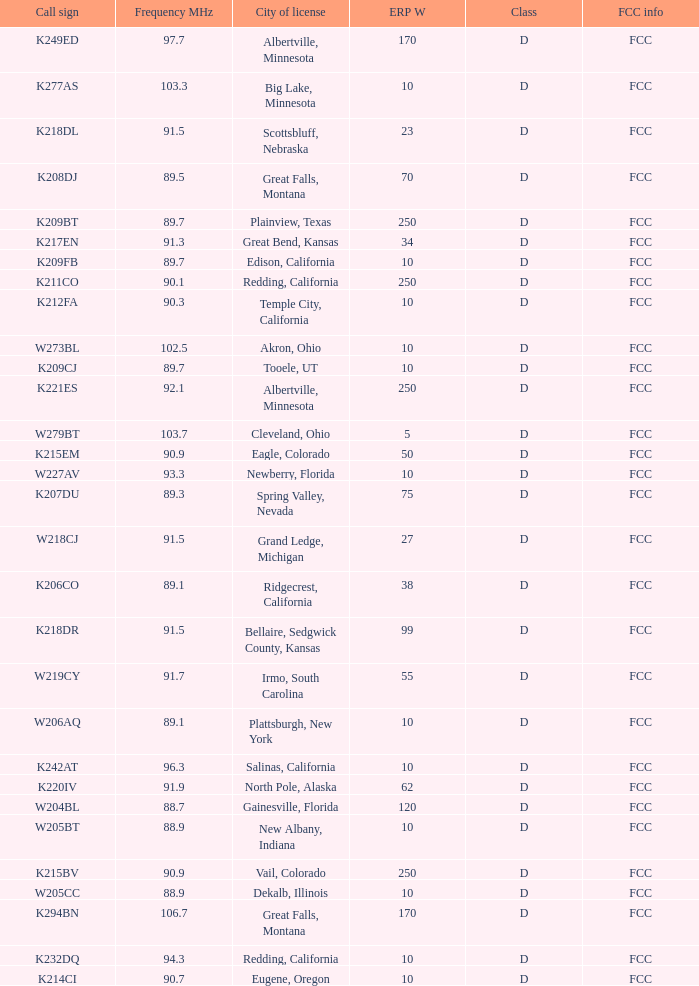What is the FCC info of the translator with an Irmo, South Carolina city license? FCC. 